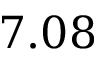<formula> <loc_0><loc_0><loc_500><loc_500>7 . 0 8</formula> 